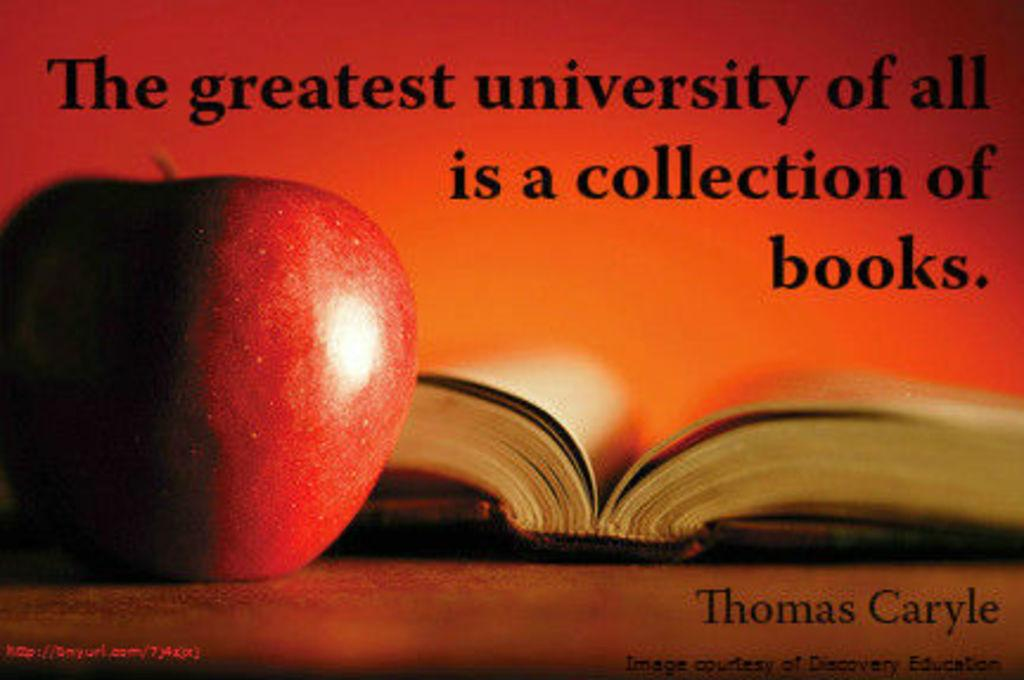<image>
Present a compact description of the photo's key features. A poster showing an apple and an open book carries a inspirational quote by Thomas Carlyle. 